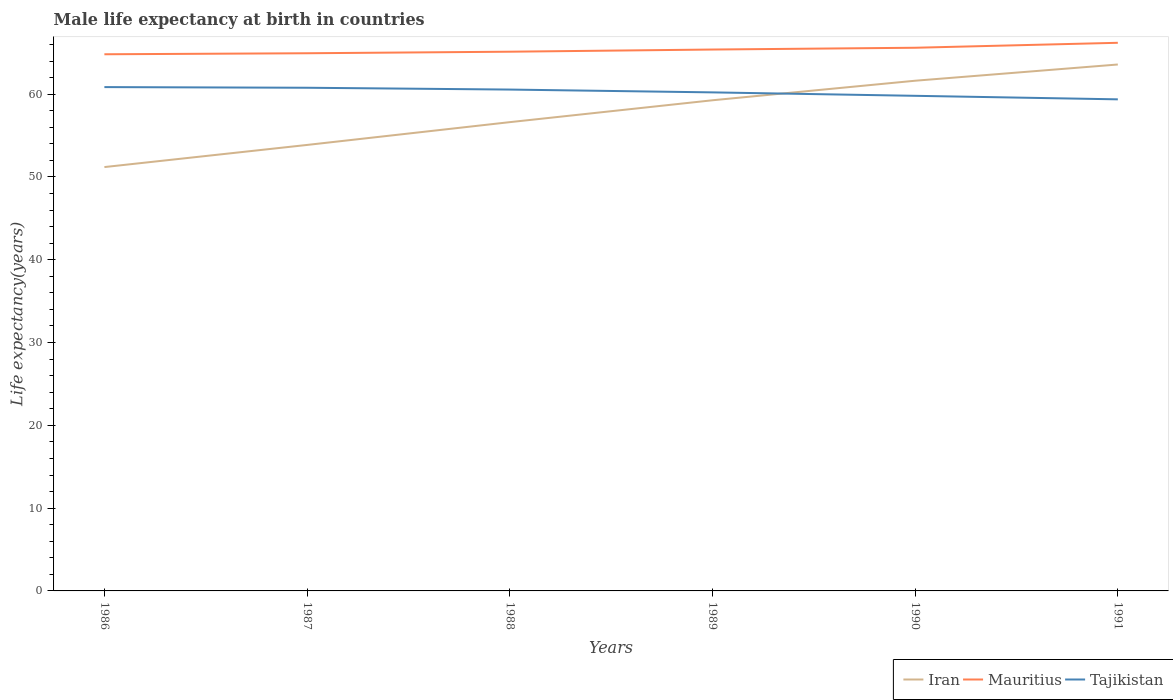Across all years, what is the maximum male life expectancy at birth in Iran?
Keep it short and to the point. 51.19. In which year was the male life expectancy at birth in Tajikistan maximum?
Ensure brevity in your answer.  1991. What is the total male life expectancy at birth in Iran in the graph?
Ensure brevity in your answer.  -7.76. What is the difference between the highest and the second highest male life expectancy at birth in Iran?
Offer a terse response. 12.39. What is the difference between the highest and the lowest male life expectancy at birth in Iran?
Provide a succinct answer. 3. What is the difference between two consecutive major ticks on the Y-axis?
Your answer should be very brief. 10. Does the graph contain grids?
Keep it short and to the point. No. How are the legend labels stacked?
Offer a very short reply. Horizontal. What is the title of the graph?
Your answer should be compact. Male life expectancy at birth in countries. Does "South Asia" appear as one of the legend labels in the graph?
Offer a very short reply. No. What is the label or title of the Y-axis?
Provide a short and direct response. Life expectancy(years). What is the Life expectancy(years) of Iran in 1986?
Provide a short and direct response. 51.19. What is the Life expectancy(years) of Mauritius in 1986?
Offer a very short reply. 64.81. What is the Life expectancy(years) in Tajikistan in 1986?
Keep it short and to the point. 60.85. What is the Life expectancy(years) in Iran in 1987?
Your answer should be compact. 53.86. What is the Life expectancy(years) of Mauritius in 1987?
Offer a terse response. 64.94. What is the Life expectancy(years) in Tajikistan in 1987?
Offer a very short reply. 60.77. What is the Life expectancy(years) of Iran in 1988?
Provide a short and direct response. 56.62. What is the Life expectancy(years) in Mauritius in 1988?
Your answer should be very brief. 65.12. What is the Life expectancy(years) of Tajikistan in 1988?
Ensure brevity in your answer.  60.55. What is the Life expectancy(years) of Iran in 1989?
Offer a very short reply. 59.26. What is the Life expectancy(years) in Mauritius in 1989?
Provide a short and direct response. 65.39. What is the Life expectancy(years) in Tajikistan in 1989?
Your response must be concise. 60.21. What is the Life expectancy(years) in Iran in 1990?
Offer a terse response. 61.62. What is the Life expectancy(years) in Mauritius in 1990?
Your answer should be compact. 65.6. What is the Life expectancy(years) of Tajikistan in 1990?
Give a very brief answer. 59.8. What is the Life expectancy(years) of Iran in 1991?
Your response must be concise. 63.58. What is the Life expectancy(years) in Mauritius in 1991?
Offer a very short reply. 66.2. What is the Life expectancy(years) in Tajikistan in 1991?
Your answer should be compact. 59.37. Across all years, what is the maximum Life expectancy(years) in Iran?
Keep it short and to the point. 63.58. Across all years, what is the maximum Life expectancy(years) of Mauritius?
Offer a terse response. 66.2. Across all years, what is the maximum Life expectancy(years) in Tajikistan?
Provide a short and direct response. 60.85. Across all years, what is the minimum Life expectancy(years) of Iran?
Provide a short and direct response. 51.19. Across all years, what is the minimum Life expectancy(years) of Mauritius?
Make the answer very short. 64.81. Across all years, what is the minimum Life expectancy(years) in Tajikistan?
Keep it short and to the point. 59.37. What is the total Life expectancy(years) in Iran in the graph?
Your answer should be compact. 346.12. What is the total Life expectancy(years) in Mauritius in the graph?
Keep it short and to the point. 392.06. What is the total Life expectancy(years) of Tajikistan in the graph?
Keep it short and to the point. 361.55. What is the difference between the Life expectancy(years) of Iran in 1986 and that in 1987?
Your response must be concise. -2.67. What is the difference between the Life expectancy(years) of Mauritius in 1986 and that in 1987?
Keep it short and to the point. -0.12. What is the difference between the Life expectancy(years) of Iran in 1986 and that in 1988?
Your response must be concise. -5.42. What is the difference between the Life expectancy(years) of Mauritius in 1986 and that in 1988?
Your answer should be compact. -0.31. What is the difference between the Life expectancy(years) of Tajikistan in 1986 and that in 1988?
Provide a succinct answer. 0.3. What is the difference between the Life expectancy(years) of Iran in 1986 and that in 1989?
Provide a short and direct response. -8.07. What is the difference between the Life expectancy(years) in Mauritius in 1986 and that in 1989?
Offer a very short reply. -0.57. What is the difference between the Life expectancy(years) in Tajikistan in 1986 and that in 1989?
Offer a terse response. 0.64. What is the difference between the Life expectancy(years) in Iran in 1986 and that in 1990?
Give a very brief answer. -10.43. What is the difference between the Life expectancy(years) of Mauritius in 1986 and that in 1990?
Make the answer very short. -0.79. What is the difference between the Life expectancy(years) in Tajikistan in 1986 and that in 1990?
Keep it short and to the point. 1.05. What is the difference between the Life expectancy(years) in Iran in 1986 and that in 1991?
Ensure brevity in your answer.  -12.39. What is the difference between the Life expectancy(years) of Mauritius in 1986 and that in 1991?
Offer a terse response. -1.39. What is the difference between the Life expectancy(years) in Tajikistan in 1986 and that in 1991?
Offer a very short reply. 1.48. What is the difference between the Life expectancy(years) of Iran in 1987 and that in 1988?
Your answer should be compact. -2.75. What is the difference between the Life expectancy(years) in Mauritius in 1987 and that in 1988?
Offer a terse response. -0.19. What is the difference between the Life expectancy(years) in Tajikistan in 1987 and that in 1988?
Ensure brevity in your answer.  0.22. What is the difference between the Life expectancy(years) in Iran in 1987 and that in 1989?
Provide a succinct answer. -5.39. What is the difference between the Life expectancy(years) in Mauritius in 1987 and that in 1989?
Offer a very short reply. -0.45. What is the difference between the Life expectancy(years) in Tajikistan in 1987 and that in 1989?
Your answer should be compact. 0.56. What is the difference between the Life expectancy(years) of Iran in 1987 and that in 1990?
Offer a very short reply. -7.75. What is the difference between the Life expectancy(years) of Mauritius in 1987 and that in 1990?
Keep it short and to the point. -0.66. What is the difference between the Life expectancy(years) in Iran in 1987 and that in 1991?
Ensure brevity in your answer.  -9.72. What is the difference between the Life expectancy(years) of Mauritius in 1987 and that in 1991?
Keep it short and to the point. -1.26. What is the difference between the Life expectancy(years) in Tajikistan in 1987 and that in 1991?
Provide a succinct answer. 1.4. What is the difference between the Life expectancy(years) of Iran in 1988 and that in 1989?
Keep it short and to the point. -2.64. What is the difference between the Life expectancy(years) of Mauritius in 1988 and that in 1989?
Keep it short and to the point. -0.26. What is the difference between the Life expectancy(years) of Tajikistan in 1988 and that in 1989?
Give a very brief answer. 0.34. What is the difference between the Life expectancy(years) of Iran in 1988 and that in 1990?
Your answer should be compact. -5. What is the difference between the Life expectancy(years) in Mauritius in 1988 and that in 1990?
Offer a very short reply. -0.48. What is the difference between the Life expectancy(years) of Tajikistan in 1988 and that in 1990?
Offer a terse response. 0.76. What is the difference between the Life expectancy(years) in Iran in 1988 and that in 1991?
Your answer should be very brief. -6.96. What is the difference between the Life expectancy(years) in Mauritius in 1988 and that in 1991?
Offer a very short reply. -1.08. What is the difference between the Life expectancy(years) of Tajikistan in 1988 and that in 1991?
Offer a terse response. 1.18. What is the difference between the Life expectancy(years) of Iran in 1989 and that in 1990?
Provide a succinct answer. -2.36. What is the difference between the Life expectancy(years) of Mauritius in 1989 and that in 1990?
Ensure brevity in your answer.  -0.21. What is the difference between the Life expectancy(years) of Tajikistan in 1989 and that in 1990?
Make the answer very short. 0.41. What is the difference between the Life expectancy(years) of Iran in 1989 and that in 1991?
Provide a succinct answer. -4.32. What is the difference between the Life expectancy(years) in Mauritius in 1989 and that in 1991?
Your answer should be very brief. -0.81. What is the difference between the Life expectancy(years) in Tajikistan in 1989 and that in 1991?
Make the answer very short. 0.84. What is the difference between the Life expectancy(years) in Iran in 1990 and that in 1991?
Offer a terse response. -1.96. What is the difference between the Life expectancy(years) of Mauritius in 1990 and that in 1991?
Your answer should be very brief. -0.6. What is the difference between the Life expectancy(years) of Tajikistan in 1990 and that in 1991?
Ensure brevity in your answer.  0.43. What is the difference between the Life expectancy(years) in Iran in 1986 and the Life expectancy(years) in Mauritius in 1987?
Provide a succinct answer. -13.75. What is the difference between the Life expectancy(years) of Iran in 1986 and the Life expectancy(years) of Tajikistan in 1987?
Provide a succinct answer. -9.58. What is the difference between the Life expectancy(years) of Mauritius in 1986 and the Life expectancy(years) of Tajikistan in 1987?
Your answer should be compact. 4.04. What is the difference between the Life expectancy(years) in Iran in 1986 and the Life expectancy(years) in Mauritius in 1988?
Offer a terse response. -13.93. What is the difference between the Life expectancy(years) of Iran in 1986 and the Life expectancy(years) of Tajikistan in 1988?
Your answer should be compact. -9.36. What is the difference between the Life expectancy(years) in Mauritius in 1986 and the Life expectancy(years) in Tajikistan in 1988?
Your answer should be very brief. 4.26. What is the difference between the Life expectancy(years) in Iran in 1986 and the Life expectancy(years) in Mauritius in 1989?
Ensure brevity in your answer.  -14.2. What is the difference between the Life expectancy(years) of Iran in 1986 and the Life expectancy(years) of Tajikistan in 1989?
Your response must be concise. -9.02. What is the difference between the Life expectancy(years) in Mauritius in 1986 and the Life expectancy(years) in Tajikistan in 1989?
Your response must be concise. 4.6. What is the difference between the Life expectancy(years) of Iran in 1986 and the Life expectancy(years) of Mauritius in 1990?
Make the answer very short. -14.41. What is the difference between the Life expectancy(years) of Iran in 1986 and the Life expectancy(years) of Tajikistan in 1990?
Offer a very short reply. -8.61. What is the difference between the Life expectancy(years) in Mauritius in 1986 and the Life expectancy(years) in Tajikistan in 1990?
Offer a terse response. 5.02. What is the difference between the Life expectancy(years) of Iran in 1986 and the Life expectancy(years) of Mauritius in 1991?
Keep it short and to the point. -15.01. What is the difference between the Life expectancy(years) of Iran in 1986 and the Life expectancy(years) of Tajikistan in 1991?
Provide a succinct answer. -8.18. What is the difference between the Life expectancy(years) in Mauritius in 1986 and the Life expectancy(years) in Tajikistan in 1991?
Your answer should be compact. 5.45. What is the difference between the Life expectancy(years) in Iran in 1987 and the Life expectancy(years) in Mauritius in 1988?
Your answer should be very brief. -11.26. What is the difference between the Life expectancy(years) in Iran in 1987 and the Life expectancy(years) in Tajikistan in 1988?
Your answer should be very brief. -6.69. What is the difference between the Life expectancy(years) of Mauritius in 1987 and the Life expectancy(years) of Tajikistan in 1988?
Your response must be concise. 4.38. What is the difference between the Life expectancy(years) in Iran in 1987 and the Life expectancy(years) in Mauritius in 1989?
Provide a succinct answer. -11.52. What is the difference between the Life expectancy(years) of Iran in 1987 and the Life expectancy(years) of Tajikistan in 1989?
Make the answer very short. -6.35. What is the difference between the Life expectancy(years) in Mauritius in 1987 and the Life expectancy(years) in Tajikistan in 1989?
Provide a short and direct response. 4.72. What is the difference between the Life expectancy(years) in Iran in 1987 and the Life expectancy(years) in Mauritius in 1990?
Your answer should be compact. -11.74. What is the difference between the Life expectancy(years) of Iran in 1987 and the Life expectancy(years) of Tajikistan in 1990?
Give a very brief answer. -5.93. What is the difference between the Life expectancy(years) of Mauritius in 1987 and the Life expectancy(years) of Tajikistan in 1990?
Offer a very short reply. 5.14. What is the difference between the Life expectancy(years) in Iran in 1987 and the Life expectancy(years) in Mauritius in 1991?
Make the answer very short. -12.34. What is the difference between the Life expectancy(years) in Iran in 1987 and the Life expectancy(years) in Tajikistan in 1991?
Provide a succinct answer. -5.51. What is the difference between the Life expectancy(years) of Mauritius in 1987 and the Life expectancy(years) of Tajikistan in 1991?
Ensure brevity in your answer.  5.57. What is the difference between the Life expectancy(years) in Iran in 1988 and the Life expectancy(years) in Mauritius in 1989?
Offer a terse response. -8.77. What is the difference between the Life expectancy(years) of Iran in 1988 and the Life expectancy(years) of Tajikistan in 1989?
Provide a succinct answer. -3.6. What is the difference between the Life expectancy(years) in Mauritius in 1988 and the Life expectancy(years) in Tajikistan in 1989?
Provide a short and direct response. 4.91. What is the difference between the Life expectancy(years) of Iran in 1988 and the Life expectancy(years) of Mauritius in 1990?
Provide a succinct answer. -8.98. What is the difference between the Life expectancy(years) of Iran in 1988 and the Life expectancy(years) of Tajikistan in 1990?
Provide a short and direct response. -3.18. What is the difference between the Life expectancy(years) of Mauritius in 1988 and the Life expectancy(years) of Tajikistan in 1990?
Ensure brevity in your answer.  5.33. What is the difference between the Life expectancy(years) in Iran in 1988 and the Life expectancy(years) in Mauritius in 1991?
Offer a terse response. -9.59. What is the difference between the Life expectancy(years) in Iran in 1988 and the Life expectancy(years) in Tajikistan in 1991?
Provide a succinct answer. -2.75. What is the difference between the Life expectancy(years) of Mauritius in 1988 and the Life expectancy(years) of Tajikistan in 1991?
Offer a very short reply. 5.75. What is the difference between the Life expectancy(years) of Iran in 1989 and the Life expectancy(years) of Mauritius in 1990?
Your response must be concise. -6.34. What is the difference between the Life expectancy(years) in Iran in 1989 and the Life expectancy(years) in Tajikistan in 1990?
Offer a terse response. -0.54. What is the difference between the Life expectancy(years) in Mauritius in 1989 and the Life expectancy(years) in Tajikistan in 1990?
Your answer should be very brief. 5.59. What is the difference between the Life expectancy(years) of Iran in 1989 and the Life expectancy(years) of Mauritius in 1991?
Make the answer very short. -6.94. What is the difference between the Life expectancy(years) of Iran in 1989 and the Life expectancy(years) of Tajikistan in 1991?
Your response must be concise. -0.11. What is the difference between the Life expectancy(years) of Mauritius in 1989 and the Life expectancy(years) of Tajikistan in 1991?
Your answer should be very brief. 6.02. What is the difference between the Life expectancy(years) of Iran in 1990 and the Life expectancy(years) of Mauritius in 1991?
Give a very brief answer. -4.58. What is the difference between the Life expectancy(years) in Iran in 1990 and the Life expectancy(years) in Tajikistan in 1991?
Ensure brevity in your answer.  2.25. What is the difference between the Life expectancy(years) in Mauritius in 1990 and the Life expectancy(years) in Tajikistan in 1991?
Your answer should be very brief. 6.23. What is the average Life expectancy(years) of Iran per year?
Make the answer very short. 57.69. What is the average Life expectancy(years) of Mauritius per year?
Give a very brief answer. 65.34. What is the average Life expectancy(years) of Tajikistan per year?
Keep it short and to the point. 60.26. In the year 1986, what is the difference between the Life expectancy(years) of Iran and Life expectancy(years) of Mauritius?
Offer a very short reply. -13.62. In the year 1986, what is the difference between the Life expectancy(years) of Iran and Life expectancy(years) of Tajikistan?
Offer a terse response. -9.66. In the year 1986, what is the difference between the Life expectancy(years) of Mauritius and Life expectancy(years) of Tajikistan?
Offer a very short reply. 3.96. In the year 1987, what is the difference between the Life expectancy(years) of Iran and Life expectancy(years) of Mauritius?
Provide a succinct answer. -11.07. In the year 1987, what is the difference between the Life expectancy(years) in Iran and Life expectancy(years) in Tajikistan?
Provide a succinct answer. -6.91. In the year 1987, what is the difference between the Life expectancy(years) of Mauritius and Life expectancy(years) of Tajikistan?
Give a very brief answer. 4.17. In the year 1988, what is the difference between the Life expectancy(years) of Iran and Life expectancy(years) of Mauritius?
Provide a succinct answer. -8.51. In the year 1988, what is the difference between the Life expectancy(years) of Iran and Life expectancy(years) of Tajikistan?
Your answer should be very brief. -3.94. In the year 1988, what is the difference between the Life expectancy(years) of Mauritius and Life expectancy(years) of Tajikistan?
Provide a succinct answer. 4.57. In the year 1989, what is the difference between the Life expectancy(years) in Iran and Life expectancy(years) in Mauritius?
Your response must be concise. -6.13. In the year 1989, what is the difference between the Life expectancy(years) of Iran and Life expectancy(years) of Tajikistan?
Provide a succinct answer. -0.95. In the year 1989, what is the difference between the Life expectancy(years) of Mauritius and Life expectancy(years) of Tajikistan?
Provide a short and direct response. 5.17. In the year 1990, what is the difference between the Life expectancy(years) in Iran and Life expectancy(years) in Mauritius?
Offer a terse response. -3.98. In the year 1990, what is the difference between the Life expectancy(years) in Iran and Life expectancy(years) in Tajikistan?
Provide a succinct answer. 1.82. In the year 1990, what is the difference between the Life expectancy(years) of Mauritius and Life expectancy(years) of Tajikistan?
Keep it short and to the point. 5.8. In the year 1991, what is the difference between the Life expectancy(years) of Iran and Life expectancy(years) of Mauritius?
Your answer should be very brief. -2.62. In the year 1991, what is the difference between the Life expectancy(years) of Iran and Life expectancy(years) of Tajikistan?
Make the answer very short. 4.21. In the year 1991, what is the difference between the Life expectancy(years) of Mauritius and Life expectancy(years) of Tajikistan?
Your response must be concise. 6.83. What is the ratio of the Life expectancy(years) of Iran in 1986 to that in 1987?
Make the answer very short. 0.95. What is the ratio of the Life expectancy(years) of Mauritius in 1986 to that in 1987?
Provide a short and direct response. 1. What is the ratio of the Life expectancy(years) in Iran in 1986 to that in 1988?
Keep it short and to the point. 0.9. What is the ratio of the Life expectancy(years) of Mauritius in 1986 to that in 1988?
Offer a very short reply. 1. What is the ratio of the Life expectancy(years) in Tajikistan in 1986 to that in 1988?
Give a very brief answer. 1. What is the ratio of the Life expectancy(years) of Iran in 1986 to that in 1989?
Your answer should be very brief. 0.86. What is the ratio of the Life expectancy(years) in Mauritius in 1986 to that in 1989?
Your response must be concise. 0.99. What is the ratio of the Life expectancy(years) in Tajikistan in 1986 to that in 1989?
Provide a short and direct response. 1.01. What is the ratio of the Life expectancy(years) in Iran in 1986 to that in 1990?
Your answer should be compact. 0.83. What is the ratio of the Life expectancy(years) of Mauritius in 1986 to that in 1990?
Keep it short and to the point. 0.99. What is the ratio of the Life expectancy(years) of Tajikistan in 1986 to that in 1990?
Your response must be concise. 1.02. What is the ratio of the Life expectancy(years) of Iran in 1986 to that in 1991?
Your answer should be very brief. 0.81. What is the ratio of the Life expectancy(years) in Mauritius in 1986 to that in 1991?
Your response must be concise. 0.98. What is the ratio of the Life expectancy(years) in Tajikistan in 1986 to that in 1991?
Provide a succinct answer. 1.02. What is the ratio of the Life expectancy(years) in Iran in 1987 to that in 1988?
Your response must be concise. 0.95. What is the ratio of the Life expectancy(years) of Iran in 1987 to that in 1989?
Your answer should be compact. 0.91. What is the ratio of the Life expectancy(years) in Mauritius in 1987 to that in 1989?
Your answer should be compact. 0.99. What is the ratio of the Life expectancy(years) of Tajikistan in 1987 to that in 1989?
Provide a succinct answer. 1.01. What is the ratio of the Life expectancy(years) in Iran in 1987 to that in 1990?
Give a very brief answer. 0.87. What is the ratio of the Life expectancy(years) of Tajikistan in 1987 to that in 1990?
Offer a very short reply. 1.02. What is the ratio of the Life expectancy(years) in Iran in 1987 to that in 1991?
Offer a terse response. 0.85. What is the ratio of the Life expectancy(years) in Mauritius in 1987 to that in 1991?
Give a very brief answer. 0.98. What is the ratio of the Life expectancy(years) in Tajikistan in 1987 to that in 1991?
Your response must be concise. 1.02. What is the ratio of the Life expectancy(years) of Iran in 1988 to that in 1989?
Ensure brevity in your answer.  0.96. What is the ratio of the Life expectancy(years) in Mauritius in 1988 to that in 1989?
Offer a very short reply. 1. What is the ratio of the Life expectancy(years) in Tajikistan in 1988 to that in 1989?
Keep it short and to the point. 1.01. What is the ratio of the Life expectancy(years) in Iran in 1988 to that in 1990?
Provide a short and direct response. 0.92. What is the ratio of the Life expectancy(years) of Mauritius in 1988 to that in 1990?
Keep it short and to the point. 0.99. What is the ratio of the Life expectancy(years) in Tajikistan in 1988 to that in 1990?
Your answer should be very brief. 1.01. What is the ratio of the Life expectancy(years) of Iran in 1988 to that in 1991?
Keep it short and to the point. 0.89. What is the ratio of the Life expectancy(years) of Mauritius in 1988 to that in 1991?
Ensure brevity in your answer.  0.98. What is the ratio of the Life expectancy(years) in Tajikistan in 1988 to that in 1991?
Your answer should be compact. 1.02. What is the ratio of the Life expectancy(years) in Iran in 1989 to that in 1990?
Provide a short and direct response. 0.96. What is the ratio of the Life expectancy(years) in Tajikistan in 1989 to that in 1990?
Your response must be concise. 1.01. What is the ratio of the Life expectancy(years) in Iran in 1989 to that in 1991?
Provide a short and direct response. 0.93. What is the ratio of the Life expectancy(years) of Mauritius in 1989 to that in 1991?
Give a very brief answer. 0.99. What is the ratio of the Life expectancy(years) in Tajikistan in 1989 to that in 1991?
Your answer should be very brief. 1.01. What is the ratio of the Life expectancy(years) in Iran in 1990 to that in 1991?
Offer a terse response. 0.97. What is the ratio of the Life expectancy(years) in Mauritius in 1990 to that in 1991?
Provide a succinct answer. 0.99. What is the difference between the highest and the second highest Life expectancy(years) of Iran?
Provide a succinct answer. 1.96. What is the difference between the highest and the second highest Life expectancy(years) of Tajikistan?
Keep it short and to the point. 0.08. What is the difference between the highest and the lowest Life expectancy(years) of Iran?
Offer a very short reply. 12.39. What is the difference between the highest and the lowest Life expectancy(years) of Mauritius?
Provide a short and direct response. 1.39. What is the difference between the highest and the lowest Life expectancy(years) of Tajikistan?
Keep it short and to the point. 1.48. 